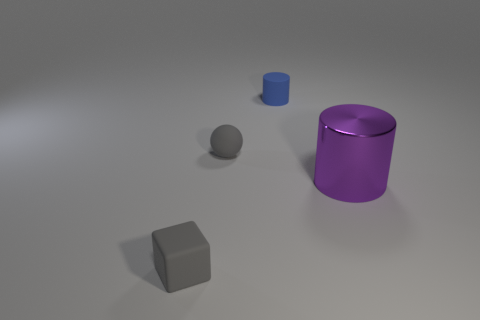Is there any other thing that has the same size as the purple cylinder?
Make the answer very short. No. There is a thing on the right side of the blue matte cylinder; does it have the same size as the gray rubber block?
Provide a short and direct response. No. How many other small objects are the same shape as the purple shiny object?
Make the answer very short. 1. There is a cube that is the same material as the sphere; what is its size?
Keep it short and to the point. Small. Are there an equal number of tiny cubes on the right side of the tiny matte cube and tiny green metal cubes?
Your answer should be very brief. Yes. Does the matte ball have the same color as the tiny rubber cylinder?
Your answer should be very brief. No. Do the small gray rubber object that is in front of the purple shiny thing and the gray rubber thing behind the big thing have the same shape?
Provide a succinct answer. No. What is the material of the purple thing that is the same shape as the blue object?
Make the answer very short. Metal. There is a object that is in front of the tiny gray rubber sphere and on the left side of the large purple shiny cylinder; what is its color?
Your answer should be very brief. Gray. Are there any objects in front of the gray thing that is in front of the cylinder on the right side of the small blue object?
Your response must be concise. No. 